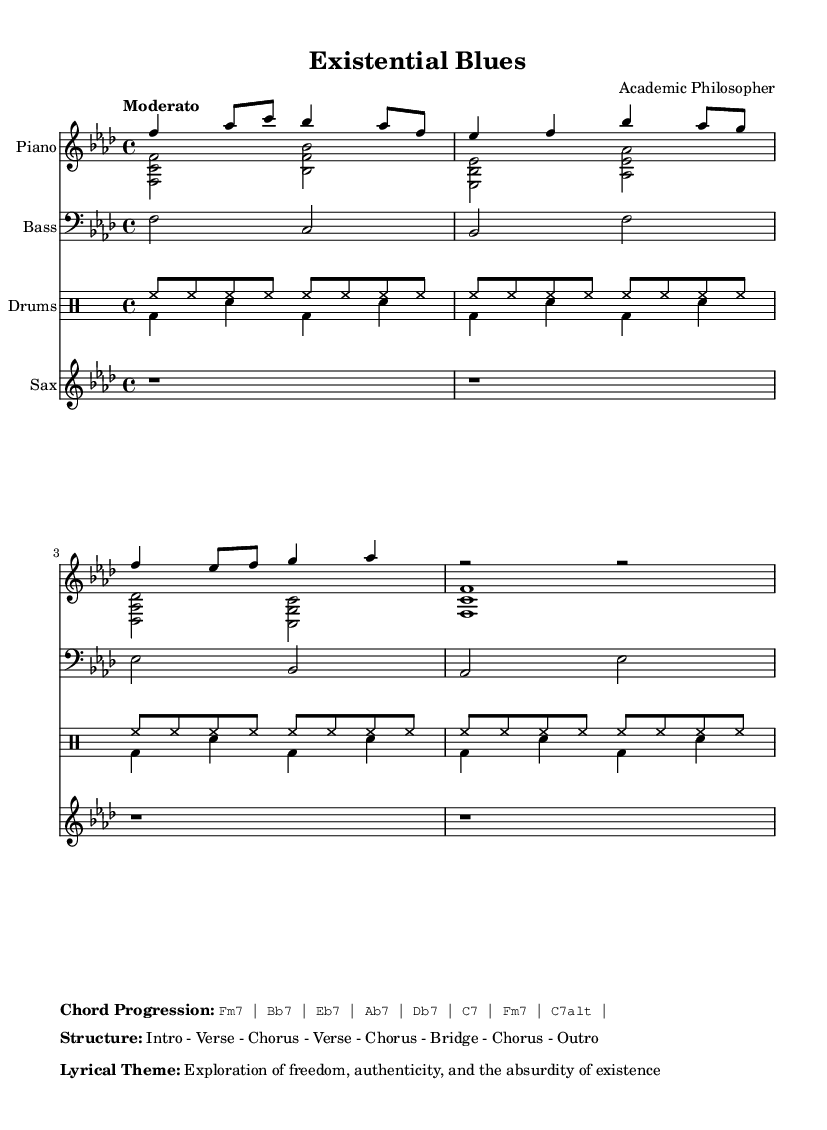What is the key signature of this music? The key signature is defined at the beginning of the score. In this case, it indicates F minor, which contains four flats.
Answer: F minor What is the time signature of this music? The time signature is indicated just after the key signature and is 4/4, meaning there are four beats in a measure and the quarter note gets one beat.
Answer: 4/4 What is the tempo marking for this composition? The tempo marking is indicated in the global section, which specifies "Moderato" suggesting a moderate tempo.
Answer: Moderato How many measures are explicitly shown for the saxophone part? The saxophone part is notated to show four whole measures (each being a rest), as there are four r1 symbols.
Answer: 4 What is the lyrical theme of the piece? The lyrical theme is explicitly stated in the markup section which describes the focus of the lyrics. It indicates themes related to freedom and the absurdity of existence.
Answer: Exploration of freedom, authenticity, and the absurdity of existence What type of chord is the first chord in the progression? Looking at the chord progression provided, the first chord indicated is Fm7, which is a minor seventh chord.
Answer: Fm7 What is the structure of the piece? The structure is given in the markup section, detailing the order of the musical sections. It specifies the order of sections including Intro, Verses, Chorus, Bridge, and Outro.
Answer: Intro - Verse - Chorus - Verse - Chorus - Bridge - Chorus - Outro 